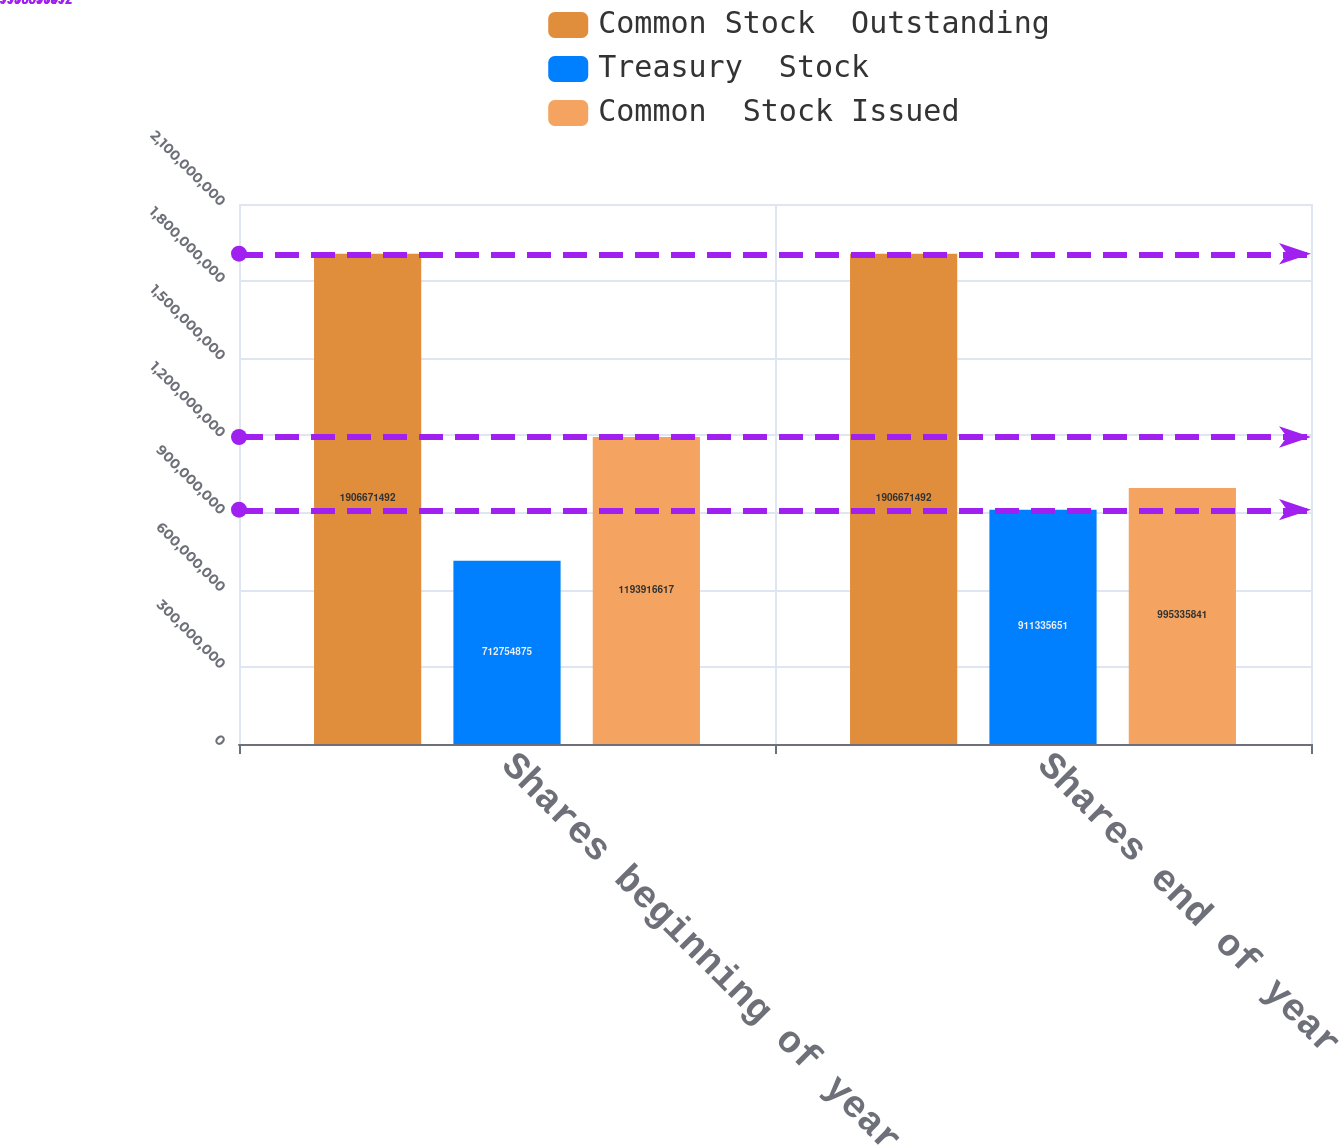Convert chart. <chart><loc_0><loc_0><loc_500><loc_500><stacked_bar_chart><ecel><fcel>Shares beginning of year<fcel>Shares end of year<nl><fcel>Common Stock  Outstanding<fcel>1.90667e+09<fcel>1.90667e+09<nl><fcel>Treasury  Stock<fcel>7.12755e+08<fcel>9.11336e+08<nl><fcel>Common  Stock Issued<fcel>1.19392e+09<fcel>9.95336e+08<nl></chart> 